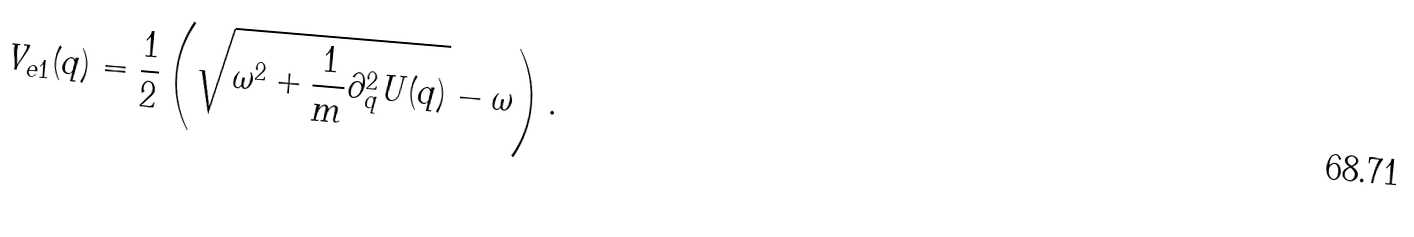<formula> <loc_0><loc_0><loc_500><loc_500>V _ { e 1 } ( q ) = \frac { 1 } { 2 } \left ( \sqrt { \omega ^ { 2 } + \frac { 1 } { m } \partial ^ { 2 } _ { q } U ( q ) } - \omega \right ) .</formula> 